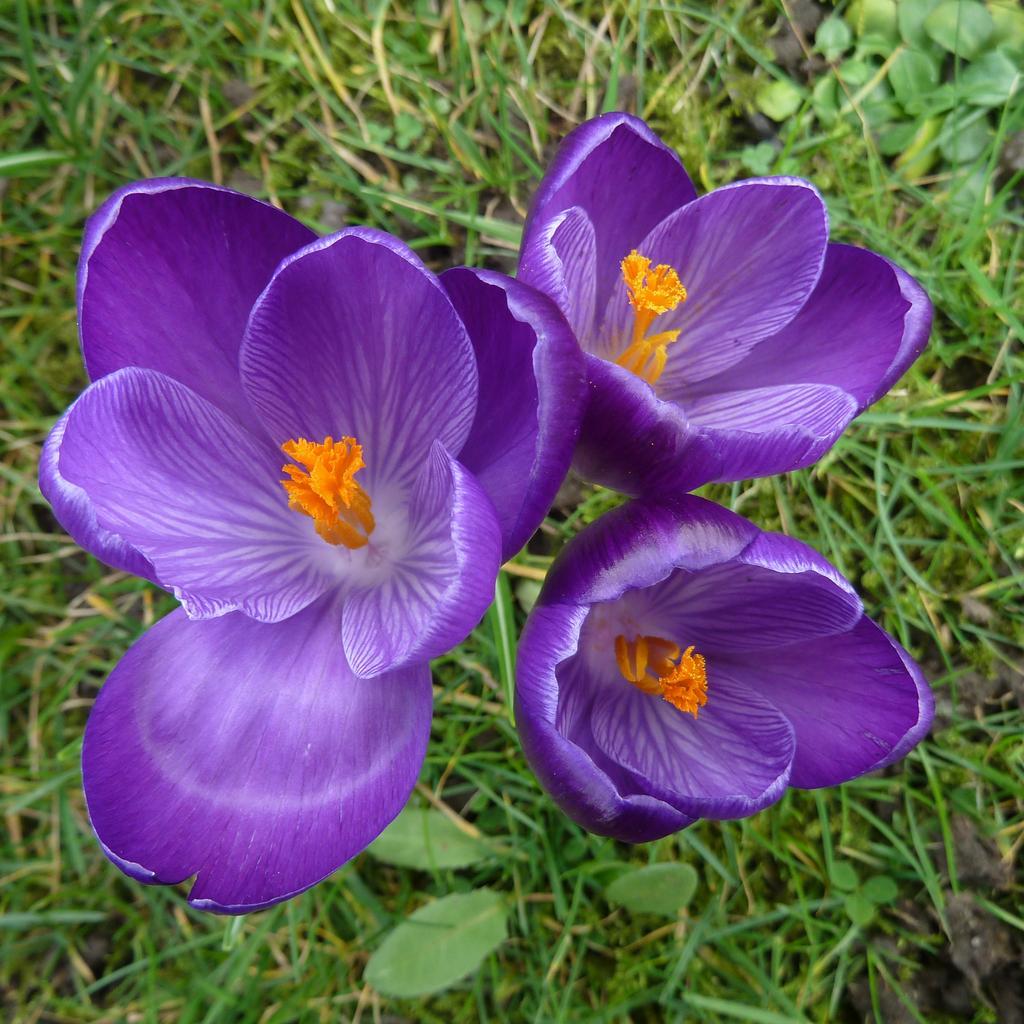Can you describe this image briefly? In this image I can see few flowers in orange and purple color. In the background I can see few plants and grass in green color. 